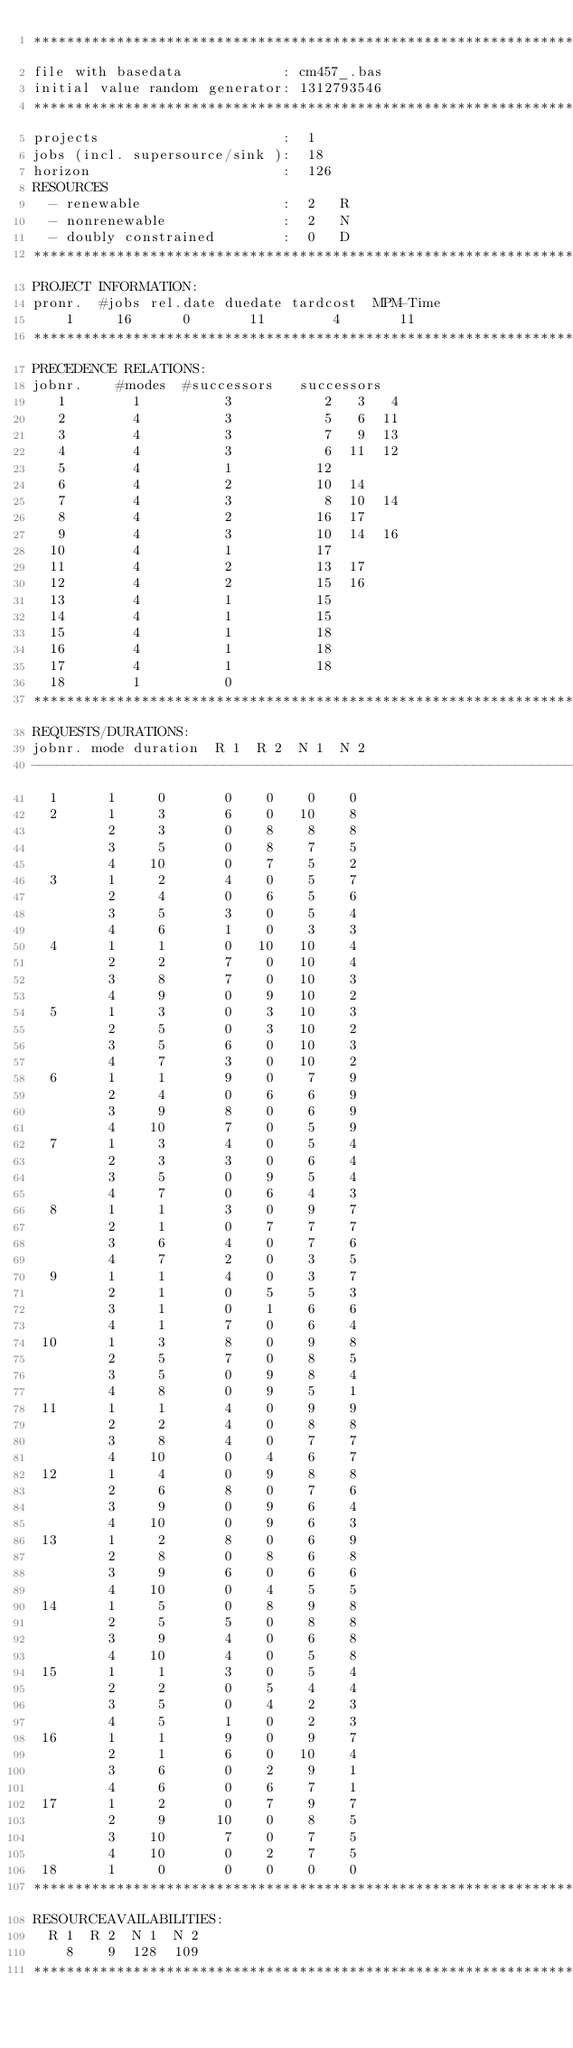<code> <loc_0><loc_0><loc_500><loc_500><_ObjectiveC_>************************************************************************
file with basedata            : cm457_.bas
initial value random generator: 1312793546
************************************************************************
projects                      :  1
jobs (incl. supersource/sink ):  18
horizon                       :  126
RESOURCES
  - renewable                 :  2   R
  - nonrenewable              :  2   N
  - doubly constrained        :  0   D
************************************************************************
PROJECT INFORMATION:
pronr.  #jobs rel.date duedate tardcost  MPM-Time
    1     16      0       11        4       11
************************************************************************
PRECEDENCE RELATIONS:
jobnr.    #modes  #successors   successors
   1        1          3           2   3   4
   2        4          3           5   6  11
   3        4          3           7   9  13
   4        4          3           6  11  12
   5        4          1          12
   6        4          2          10  14
   7        4          3           8  10  14
   8        4          2          16  17
   9        4          3          10  14  16
  10        4          1          17
  11        4          2          13  17
  12        4          2          15  16
  13        4          1          15
  14        4          1          15
  15        4          1          18
  16        4          1          18
  17        4          1          18
  18        1          0        
************************************************************************
REQUESTS/DURATIONS:
jobnr. mode duration  R 1  R 2  N 1  N 2
------------------------------------------------------------------------
  1      1     0       0    0    0    0
  2      1     3       6    0   10    8
         2     3       0    8    8    8
         3     5       0    8    7    5
         4    10       0    7    5    2
  3      1     2       4    0    5    7
         2     4       0    6    5    6
         3     5       3    0    5    4
         4     6       1    0    3    3
  4      1     1       0   10   10    4
         2     2       7    0   10    4
         3     8       7    0   10    3
         4     9       0    9   10    2
  5      1     3       0    3   10    3
         2     5       0    3   10    2
         3     5       6    0   10    3
         4     7       3    0   10    2
  6      1     1       9    0    7    9
         2     4       0    6    6    9
         3     9       8    0    6    9
         4    10       7    0    5    9
  7      1     3       4    0    5    4
         2     3       3    0    6    4
         3     5       0    9    5    4
         4     7       0    6    4    3
  8      1     1       3    0    9    7
         2     1       0    7    7    7
         3     6       4    0    7    6
         4     7       2    0    3    5
  9      1     1       4    0    3    7
         2     1       0    5    5    3
         3     1       0    1    6    6
         4     1       7    0    6    4
 10      1     3       8    0    9    8
         2     5       7    0    8    5
         3     5       0    9    8    4
         4     8       0    9    5    1
 11      1     1       4    0    9    9
         2     2       4    0    8    8
         3     8       4    0    7    7
         4    10       0    4    6    7
 12      1     4       0    9    8    8
         2     6       8    0    7    6
         3     9       0    9    6    4
         4    10       0    9    6    3
 13      1     2       8    0    6    9
         2     8       0    8    6    8
         3     9       6    0    6    6
         4    10       0    4    5    5
 14      1     5       0    8    9    8
         2     5       5    0    8    8
         3     9       4    0    6    8
         4    10       4    0    5    8
 15      1     1       3    0    5    4
         2     2       0    5    4    4
         3     5       0    4    2    3
         4     5       1    0    2    3
 16      1     1       9    0    9    7
         2     1       6    0   10    4
         3     6       0    2    9    1
         4     6       0    6    7    1
 17      1     2       0    7    9    7
         2     9      10    0    8    5
         3    10       7    0    7    5
         4    10       0    2    7    5
 18      1     0       0    0    0    0
************************************************************************
RESOURCEAVAILABILITIES:
  R 1  R 2  N 1  N 2
    8    9  128  109
************************************************************************
</code> 